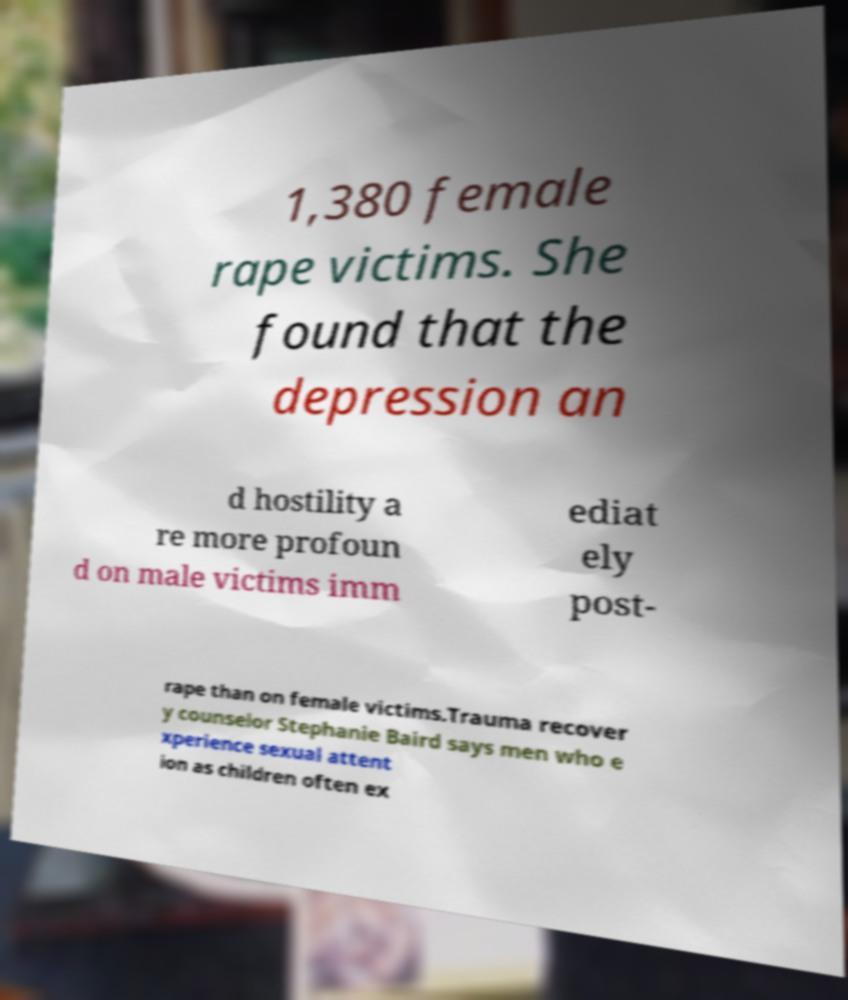Please identify and transcribe the text found in this image. 1,380 female rape victims. She found that the depression an d hostility a re more profoun d on male victims imm ediat ely post- rape than on female victims.Trauma recover y counselor Stephanie Baird says men who e xperience sexual attent ion as children often ex 